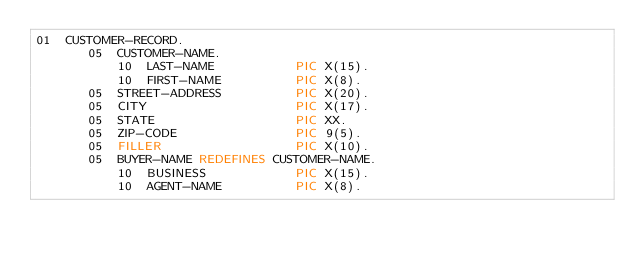<code> <loc_0><loc_0><loc_500><loc_500><_COBOL_>01  CUSTOMER-RECORD.
       05  CUSTOMER-NAME.
           10  LAST-NAME           PIC X(15).
           10  FIRST-NAME          PIC X(8).
       05  STREET-ADDRESS          PIC X(20).
       05  CITY                    PIC X(17).
       05  STATE                   PIC XX.
       05  ZIP-CODE                PIC 9(5).
       05  FILLER                  PIC X(10).
       05  BUYER-NAME REDEFINES CUSTOMER-NAME.
           10  BUSINESS            PIC X(15).
           10  AGENT-NAME          PIC X(8).
</code> 